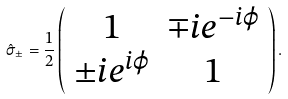Convert formula to latex. <formula><loc_0><loc_0><loc_500><loc_500>\hat { \sigma } _ { \pm } = \frac { 1 } { 2 } \left ( \begin{array} { c c } 1 & \mp i e ^ { - i \varphi } \\ \pm i e ^ { i \varphi } & 1 \end{array} \right ) .</formula> 